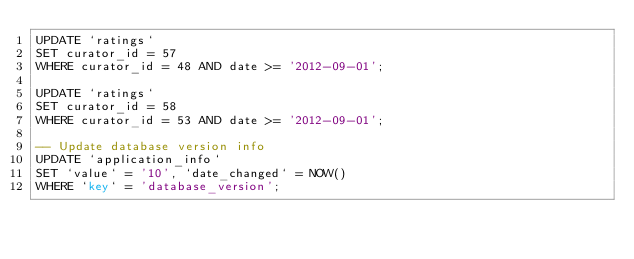Convert code to text. <code><loc_0><loc_0><loc_500><loc_500><_SQL_>UPDATE `ratings`
SET curator_id = 57
WHERE curator_id = 48 AND date >= '2012-09-01';

UPDATE `ratings`
SET curator_id = 58
WHERE curator_id = 53 AND date >= '2012-09-01';

-- Update database version info
UPDATE `application_info`
SET `value` = '10', `date_changed` = NOW()
WHERE `key` = 'database_version';

</code> 